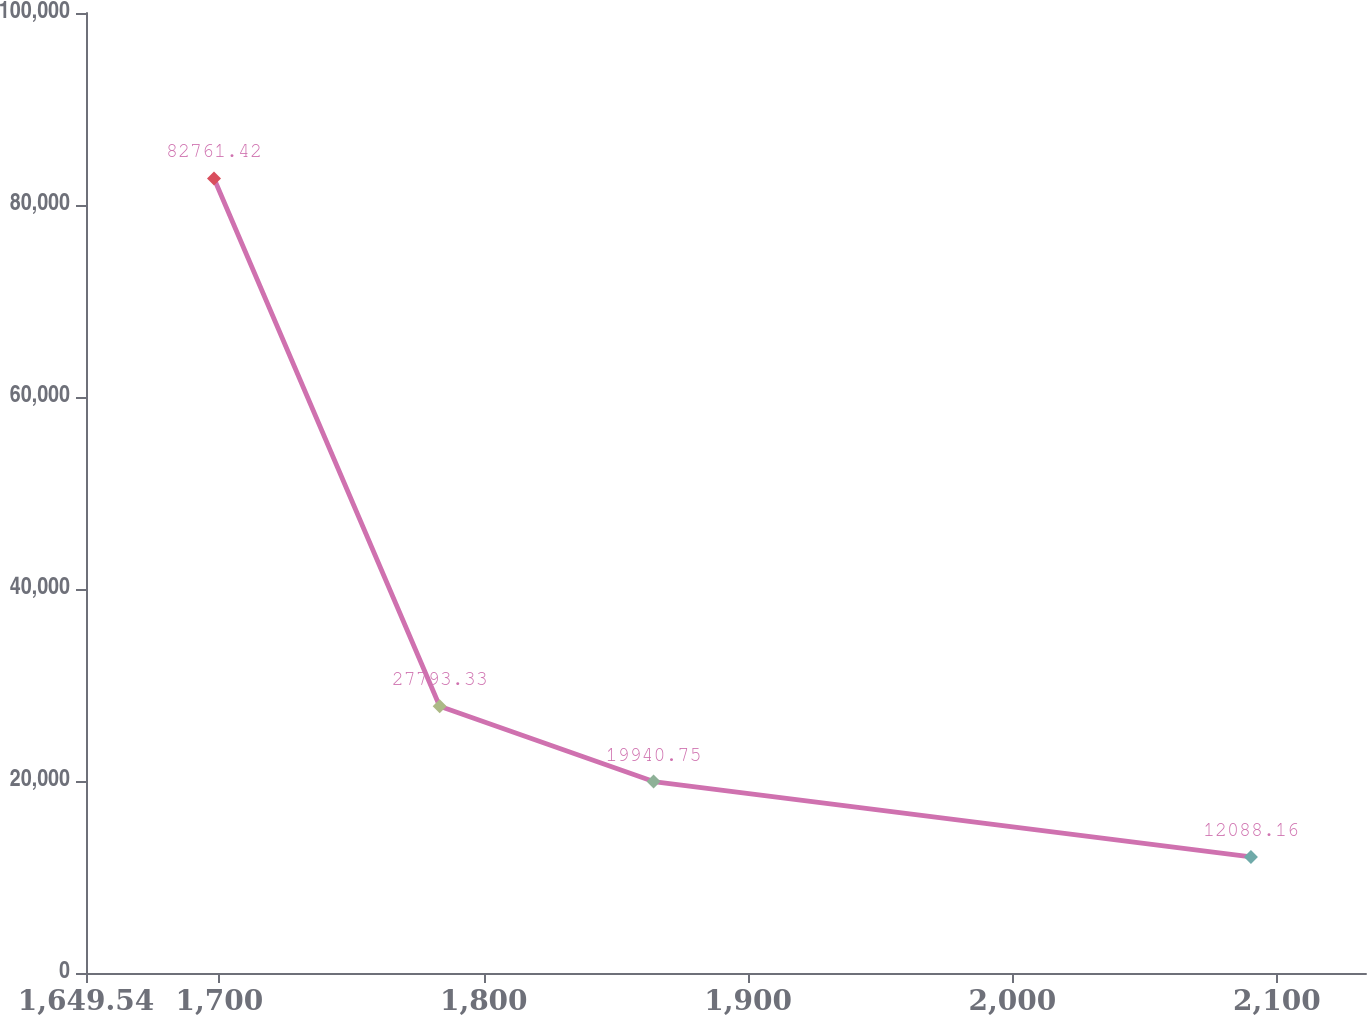Convert chart to OTSL. <chart><loc_0><loc_0><loc_500><loc_500><line_chart><ecel><fcel>Unnamed: 1<nl><fcel>1697.96<fcel>82761.4<nl><fcel>1783.34<fcel>27793.3<nl><fcel>1864.25<fcel>19940.8<nl><fcel>2090.22<fcel>12088.2<nl><fcel>2182.16<fcel>4235.57<nl></chart> 